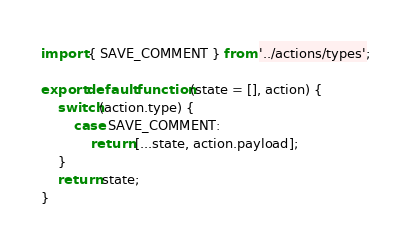<code> <loc_0><loc_0><loc_500><loc_500><_JavaScript_>import { SAVE_COMMENT } from '../actions/types';

export default function(state = [], action) {
    switch(action.type) {
        case SAVE_COMMENT:
            return [...state, action.payload];
    }
    return state;
}</code> 